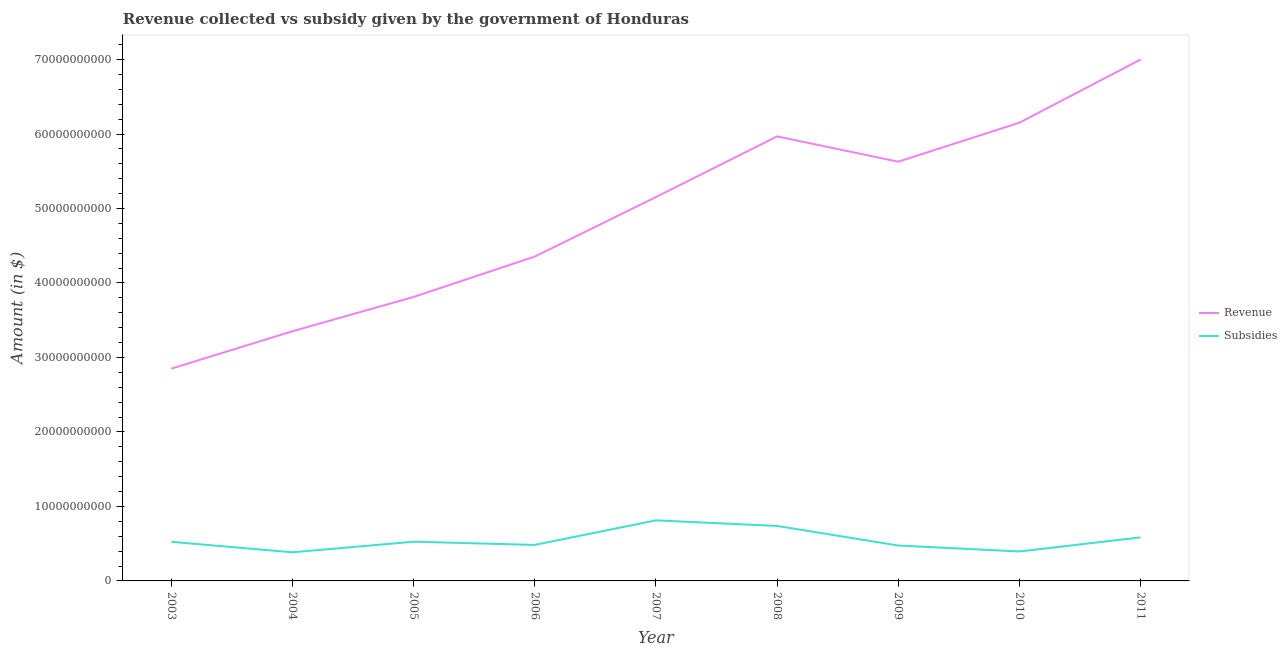How many different coloured lines are there?
Offer a terse response. 2. Does the line corresponding to amount of revenue collected intersect with the line corresponding to amount of subsidies given?
Make the answer very short. No. Is the number of lines equal to the number of legend labels?
Your response must be concise. Yes. What is the amount of revenue collected in 2011?
Make the answer very short. 7.00e+1. Across all years, what is the maximum amount of revenue collected?
Keep it short and to the point. 7.00e+1. Across all years, what is the minimum amount of revenue collected?
Offer a very short reply. 2.85e+1. In which year was the amount of subsidies given maximum?
Offer a very short reply. 2007. What is the total amount of revenue collected in the graph?
Your answer should be very brief. 4.43e+11. What is the difference between the amount of revenue collected in 2005 and that in 2006?
Offer a very short reply. -5.42e+09. What is the difference between the amount of revenue collected in 2006 and the amount of subsidies given in 2007?
Your response must be concise. 3.54e+1. What is the average amount of revenue collected per year?
Provide a short and direct response. 4.92e+1. In the year 2011, what is the difference between the amount of subsidies given and amount of revenue collected?
Give a very brief answer. -6.42e+1. In how many years, is the amount of subsidies given greater than 42000000000 $?
Offer a very short reply. 0. What is the ratio of the amount of revenue collected in 2004 to that in 2008?
Keep it short and to the point. 0.56. What is the difference between the highest and the second highest amount of subsidies given?
Give a very brief answer. 7.53e+08. What is the difference between the highest and the lowest amount of subsidies given?
Provide a short and direct response. 4.29e+09. Is the sum of the amount of subsidies given in 2003 and 2010 greater than the maximum amount of revenue collected across all years?
Ensure brevity in your answer.  No. Does the amount of revenue collected monotonically increase over the years?
Keep it short and to the point. No. Is the amount of subsidies given strictly greater than the amount of revenue collected over the years?
Your answer should be very brief. No. Is the amount of subsidies given strictly less than the amount of revenue collected over the years?
Make the answer very short. Yes. How many years are there in the graph?
Provide a succinct answer. 9. What is the difference between two consecutive major ticks on the Y-axis?
Your answer should be very brief. 1.00e+1. Does the graph contain any zero values?
Keep it short and to the point. No. Does the graph contain grids?
Your response must be concise. No. Where does the legend appear in the graph?
Keep it short and to the point. Center right. What is the title of the graph?
Your answer should be compact. Revenue collected vs subsidy given by the government of Honduras. What is the label or title of the X-axis?
Your answer should be very brief. Year. What is the label or title of the Y-axis?
Ensure brevity in your answer.  Amount (in $). What is the Amount (in $) of Revenue in 2003?
Ensure brevity in your answer.  2.85e+1. What is the Amount (in $) in Subsidies in 2003?
Keep it short and to the point. 5.25e+09. What is the Amount (in $) in Revenue in 2004?
Keep it short and to the point. 3.35e+1. What is the Amount (in $) in Subsidies in 2004?
Give a very brief answer. 3.84e+09. What is the Amount (in $) of Revenue in 2005?
Make the answer very short. 3.81e+1. What is the Amount (in $) of Subsidies in 2005?
Your response must be concise. 5.27e+09. What is the Amount (in $) in Revenue in 2006?
Your answer should be compact. 4.35e+1. What is the Amount (in $) of Subsidies in 2006?
Offer a very short reply. 4.83e+09. What is the Amount (in $) of Revenue in 2007?
Ensure brevity in your answer.  5.15e+1. What is the Amount (in $) of Subsidies in 2007?
Offer a terse response. 8.13e+09. What is the Amount (in $) of Revenue in 2008?
Your answer should be compact. 5.97e+1. What is the Amount (in $) in Subsidies in 2008?
Provide a short and direct response. 7.38e+09. What is the Amount (in $) in Revenue in 2009?
Provide a short and direct response. 5.63e+1. What is the Amount (in $) in Subsidies in 2009?
Keep it short and to the point. 4.75e+09. What is the Amount (in $) of Revenue in 2010?
Your answer should be very brief. 6.15e+1. What is the Amount (in $) of Subsidies in 2010?
Your answer should be very brief. 3.95e+09. What is the Amount (in $) in Revenue in 2011?
Your response must be concise. 7.00e+1. What is the Amount (in $) in Subsidies in 2011?
Your answer should be compact. 5.84e+09. Across all years, what is the maximum Amount (in $) in Revenue?
Your response must be concise. 7.00e+1. Across all years, what is the maximum Amount (in $) of Subsidies?
Your answer should be compact. 8.13e+09. Across all years, what is the minimum Amount (in $) in Revenue?
Offer a terse response. 2.85e+1. Across all years, what is the minimum Amount (in $) in Subsidies?
Give a very brief answer. 3.84e+09. What is the total Amount (in $) of Revenue in the graph?
Your answer should be compact. 4.43e+11. What is the total Amount (in $) in Subsidies in the graph?
Offer a very short reply. 4.93e+1. What is the difference between the Amount (in $) of Revenue in 2003 and that in 2004?
Provide a succinct answer. -5.02e+09. What is the difference between the Amount (in $) in Subsidies in 2003 and that in 2004?
Make the answer very short. 1.41e+09. What is the difference between the Amount (in $) of Revenue in 2003 and that in 2005?
Your response must be concise. -9.63e+09. What is the difference between the Amount (in $) in Subsidies in 2003 and that in 2005?
Offer a terse response. -1.57e+07. What is the difference between the Amount (in $) in Revenue in 2003 and that in 2006?
Offer a terse response. -1.50e+1. What is the difference between the Amount (in $) of Subsidies in 2003 and that in 2006?
Make the answer very short. 4.17e+08. What is the difference between the Amount (in $) in Revenue in 2003 and that in 2007?
Ensure brevity in your answer.  -2.30e+1. What is the difference between the Amount (in $) of Subsidies in 2003 and that in 2007?
Make the answer very short. -2.88e+09. What is the difference between the Amount (in $) of Revenue in 2003 and that in 2008?
Offer a very short reply. -3.12e+1. What is the difference between the Amount (in $) in Subsidies in 2003 and that in 2008?
Provide a succinct answer. -2.13e+09. What is the difference between the Amount (in $) in Revenue in 2003 and that in 2009?
Your answer should be very brief. -2.78e+1. What is the difference between the Amount (in $) in Subsidies in 2003 and that in 2009?
Provide a succinct answer. 4.99e+08. What is the difference between the Amount (in $) of Revenue in 2003 and that in 2010?
Provide a short and direct response. -3.30e+1. What is the difference between the Amount (in $) in Subsidies in 2003 and that in 2010?
Ensure brevity in your answer.  1.30e+09. What is the difference between the Amount (in $) of Revenue in 2003 and that in 2011?
Ensure brevity in your answer.  -4.15e+1. What is the difference between the Amount (in $) in Subsidies in 2003 and that in 2011?
Provide a short and direct response. -5.92e+08. What is the difference between the Amount (in $) of Revenue in 2004 and that in 2005?
Give a very brief answer. -4.61e+09. What is the difference between the Amount (in $) of Subsidies in 2004 and that in 2005?
Keep it short and to the point. -1.43e+09. What is the difference between the Amount (in $) in Revenue in 2004 and that in 2006?
Offer a terse response. -1.00e+1. What is the difference between the Amount (in $) in Subsidies in 2004 and that in 2006?
Provide a succinct answer. -9.93e+08. What is the difference between the Amount (in $) of Revenue in 2004 and that in 2007?
Offer a very short reply. -1.80e+1. What is the difference between the Amount (in $) in Subsidies in 2004 and that in 2007?
Provide a short and direct response. -4.29e+09. What is the difference between the Amount (in $) of Revenue in 2004 and that in 2008?
Keep it short and to the point. -2.62e+1. What is the difference between the Amount (in $) of Subsidies in 2004 and that in 2008?
Offer a very short reply. -3.54e+09. What is the difference between the Amount (in $) in Revenue in 2004 and that in 2009?
Make the answer very short. -2.28e+1. What is the difference between the Amount (in $) of Subsidies in 2004 and that in 2009?
Make the answer very short. -9.11e+08. What is the difference between the Amount (in $) of Revenue in 2004 and that in 2010?
Offer a terse response. -2.80e+1. What is the difference between the Amount (in $) of Subsidies in 2004 and that in 2010?
Offer a very short reply. -1.11e+08. What is the difference between the Amount (in $) in Revenue in 2004 and that in 2011?
Make the answer very short. -3.65e+1. What is the difference between the Amount (in $) of Subsidies in 2004 and that in 2011?
Make the answer very short. -2.00e+09. What is the difference between the Amount (in $) of Revenue in 2005 and that in 2006?
Provide a succinct answer. -5.42e+09. What is the difference between the Amount (in $) in Subsidies in 2005 and that in 2006?
Offer a terse response. 4.33e+08. What is the difference between the Amount (in $) in Revenue in 2005 and that in 2007?
Your answer should be very brief. -1.34e+1. What is the difference between the Amount (in $) in Subsidies in 2005 and that in 2007?
Your answer should be very brief. -2.87e+09. What is the difference between the Amount (in $) in Revenue in 2005 and that in 2008?
Give a very brief answer. -2.16e+1. What is the difference between the Amount (in $) in Subsidies in 2005 and that in 2008?
Keep it short and to the point. -2.11e+09. What is the difference between the Amount (in $) of Revenue in 2005 and that in 2009?
Your answer should be compact. -1.82e+1. What is the difference between the Amount (in $) of Subsidies in 2005 and that in 2009?
Your answer should be very brief. 5.14e+08. What is the difference between the Amount (in $) of Revenue in 2005 and that in 2010?
Keep it short and to the point. -2.34e+1. What is the difference between the Amount (in $) in Subsidies in 2005 and that in 2010?
Your response must be concise. 1.31e+09. What is the difference between the Amount (in $) in Revenue in 2005 and that in 2011?
Your answer should be compact. -3.19e+1. What is the difference between the Amount (in $) of Subsidies in 2005 and that in 2011?
Ensure brevity in your answer.  -5.76e+08. What is the difference between the Amount (in $) in Revenue in 2006 and that in 2007?
Make the answer very short. -7.99e+09. What is the difference between the Amount (in $) in Subsidies in 2006 and that in 2007?
Give a very brief answer. -3.30e+09. What is the difference between the Amount (in $) in Revenue in 2006 and that in 2008?
Give a very brief answer. -1.61e+1. What is the difference between the Amount (in $) of Subsidies in 2006 and that in 2008?
Offer a terse response. -2.55e+09. What is the difference between the Amount (in $) of Revenue in 2006 and that in 2009?
Keep it short and to the point. -1.27e+1. What is the difference between the Amount (in $) in Subsidies in 2006 and that in 2009?
Provide a short and direct response. 8.13e+07. What is the difference between the Amount (in $) of Revenue in 2006 and that in 2010?
Provide a succinct answer. -1.80e+1. What is the difference between the Amount (in $) in Subsidies in 2006 and that in 2010?
Make the answer very short. 8.81e+08. What is the difference between the Amount (in $) of Revenue in 2006 and that in 2011?
Keep it short and to the point. -2.65e+1. What is the difference between the Amount (in $) of Subsidies in 2006 and that in 2011?
Your answer should be compact. -1.01e+09. What is the difference between the Amount (in $) of Revenue in 2007 and that in 2008?
Keep it short and to the point. -8.15e+09. What is the difference between the Amount (in $) of Subsidies in 2007 and that in 2008?
Your response must be concise. 7.53e+08. What is the difference between the Amount (in $) of Revenue in 2007 and that in 2009?
Provide a short and direct response. -4.75e+09. What is the difference between the Amount (in $) in Subsidies in 2007 and that in 2009?
Make the answer very short. 3.38e+09. What is the difference between the Amount (in $) in Revenue in 2007 and that in 2010?
Provide a short and direct response. -9.98e+09. What is the difference between the Amount (in $) in Subsidies in 2007 and that in 2010?
Make the answer very short. 4.18e+09. What is the difference between the Amount (in $) in Revenue in 2007 and that in 2011?
Your response must be concise. -1.85e+1. What is the difference between the Amount (in $) of Subsidies in 2007 and that in 2011?
Your answer should be compact. 2.29e+09. What is the difference between the Amount (in $) in Revenue in 2008 and that in 2009?
Your response must be concise. 3.40e+09. What is the difference between the Amount (in $) in Subsidies in 2008 and that in 2009?
Give a very brief answer. 2.63e+09. What is the difference between the Amount (in $) of Revenue in 2008 and that in 2010?
Make the answer very short. -1.84e+09. What is the difference between the Amount (in $) of Subsidies in 2008 and that in 2010?
Your response must be concise. 3.43e+09. What is the difference between the Amount (in $) of Revenue in 2008 and that in 2011?
Make the answer very short. -1.03e+1. What is the difference between the Amount (in $) of Subsidies in 2008 and that in 2011?
Provide a succinct answer. 1.54e+09. What is the difference between the Amount (in $) of Revenue in 2009 and that in 2010?
Offer a terse response. -5.23e+09. What is the difference between the Amount (in $) of Subsidies in 2009 and that in 2010?
Provide a succinct answer. 8.00e+08. What is the difference between the Amount (in $) of Revenue in 2009 and that in 2011?
Provide a succinct answer. -1.37e+1. What is the difference between the Amount (in $) in Subsidies in 2009 and that in 2011?
Ensure brevity in your answer.  -1.09e+09. What is the difference between the Amount (in $) in Revenue in 2010 and that in 2011?
Your answer should be very brief. -8.49e+09. What is the difference between the Amount (in $) in Subsidies in 2010 and that in 2011?
Give a very brief answer. -1.89e+09. What is the difference between the Amount (in $) of Revenue in 2003 and the Amount (in $) of Subsidies in 2004?
Give a very brief answer. 2.47e+1. What is the difference between the Amount (in $) in Revenue in 2003 and the Amount (in $) in Subsidies in 2005?
Your response must be concise. 2.32e+1. What is the difference between the Amount (in $) of Revenue in 2003 and the Amount (in $) of Subsidies in 2006?
Ensure brevity in your answer.  2.37e+1. What is the difference between the Amount (in $) in Revenue in 2003 and the Amount (in $) in Subsidies in 2007?
Ensure brevity in your answer.  2.04e+1. What is the difference between the Amount (in $) of Revenue in 2003 and the Amount (in $) of Subsidies in 2008?
Your answer should be very brief. 2.11e+1. What is the difference between the Amount (in $) in Revenue in 2003 and the Amount (in $) in Subsidies in 2009?
Give a very brief answer. 2.37e+1. What is the difference between the Amount (in $) of Revenue in 2003 and the Amount (in $) of Subsidies in 2010?
Your response must be concise. 2.45e+1. What is the difference between the Amount (in $) in Revenue in 2003 and the Amount (in $) in Subsidies in 2011?
Your answer should be very brief. 2.27e+1. What is the difference between the Amount (in $) in Revenue in 2004 and the Amount (in $) in Subsidies in 2005?
Give a very brief answer. 2.83e+1. What is the difference between the Amount (in $) in Revenue in 2004 and the Amount (in $) in Subsidies in 2006?
Ensure brevity in your answer.  2.87e+1. What is the difference between the Amount (in $) in Revenue in 2004 and the Amount (in $) in Subsidies in 2007?
Provide a succinct answer. 2.54e+1. What is the difference between the Amount (in $) of Revenue in 2004 and the Amount (in $) of Subsidies in 2008?
Provide a succinct answer. 2.61e+1. What is the difference between the Amount (in $) in Revenue in 2004 and the Amount (in $) in Subsidies in 2009?
Offer a terse response. 2.88e+1. What is the difference between the Amount (in $) of Revenue in 2004 and the Amount (in $) of Subsidies in 2010?
Provide a short and direct response. 2.96e+1. What is the difference between the Amount (in $) of Revenue in 2004 and the Amount (in $) of Subsidies in 2011?
Give a very brief answer. 2.77e+1. What is the difference between the Amount (in $) of Revenue in 2005 and the Amount (in $) of Subsidies in 2006?
Ensure brevity in your answer.  3.33e+1. What is the difference between the Amount (in $) of Revenue in 2005 and the Amount (in $) of Subsidies in 2007?
Your answer should be compact. 3.00e+1. What is the difference between the Amount (in $) of Revenue in 2005 and the Amount (in $) of Subsidies in 2008?
Provide a succinct answer. 3.07e+1. What is the difference between the Amount (in $) in Revenue in 2005 and the Amount (in $) in Subsidies in 2009?
Provide a succinct answer. 3.34e+1. What is the difference between the Amount (in $) of Revenue in 2005 and the Amount (in $) of Subsidies in 2010?
Your response must be concise. 3.42e+1. What is the difference between the Amount (in $) of Revenue in 2005 and the Amount (in $) of Subsidies in 2011?
Provide a succinct answer. 3.23e+1. What is the difference between the Amount (in $) in Revenue in 2006 and the Amount (in $) in Subsidies in 2007?
Provide a succinct answer. 3.54e+1. What is the difference between the Amount (in $) in Revenue in 2006 and the Amount (in $) in Subsidies in 2008?
Your answer should be compact. 3.62e+1. What is the difference between the Amount (in $) in Revenue in 2006 and the Amount (in $) in Subsidies in 2009?
Give a very brief answer. 3.88e+1. What is the difference between the Amount (in $) in Revenue in 2006 and the Amount (in $) in Subsidies in 2010?
Your response must be concise. 3.96e+1. What is the difference between the Amount (in $) in Revenue in 2006 and the Amount (in $) in Subsidies in 2011?
Keep it short and to the point. 3.77e+1. What is the difference between the Amount (in $) of Revenue in 2007 and the Amount (in $) of Subsidies in 2008?
Provide a short and direct response. 4.42e+1. What is the difference between the Amount (in $) of Revenue in 2007 and the Amount (in $) of Subsidies in 2009?
Provide a short and direct response. 4.68e+1. What is the difference between the Amount (in $) of Revenue in 2007 and the Amount (in $) of Subsidies in 2010?
Offer a terse response. 4.76e+1. What is the difference between the Amount (in $) of Revenue in 2007 and the Amount (in $) of Subsidies in 2011?
Make the answer very short. 4.57e+1. What is the difference between the Amount (in $) of Revenue in 2008 and the Amount (in $) of Subsidies in 2009?
Your response must be concise. 5.49e+1. What is the difference between the Amount (in $) in Revenue in 2008 and the Amount (in $) in Subsidies in 2010?
Give a very brief answer. 5.57e+1. What is the difference between the Amount (in $) of Revenue in 2008 and the Amount (in $) of Subsidies in 2011?
Your response must be concise. 5.38e+1. What is the difference between the Amount (in $) of Revenue in 2009 and the Amount (in $) of Subsidies in 2010?
Give a very brief answer. 5.23e+1. What is the difference between the Amount (in $) of Revenue in 2009 and the Amount (in $) of Subsidies in 2011?
Provide a succinct answer. 5.04e+1. What is the difference between the Amount (in $) of Revenue in 2010 and the Amount (in $) of Subsidies in 2011?
Give a very brief answer. 5.57e+1. What is the average Amount (in $) in Revenue per year?
Ensure brevity in your answer.  4.92e+1. What is the average Amount (in $) of Subsidies per year?
Offer a very short reply. 5.47e+09. In the year 2003, what is the difference between the Amount (in $) in Revenue and Amount (in $) in Subsidies?
Keep it short and to the point. 2.32e+1. In the year 2004, what is the difference between the Amount (in $) in Revenue and Amount (in $) in Subsidies?
Make the answer very short. 2.97e+1. In the year 2005, what is the difference between the Amount (in $) of Revenue and Amount (in $) of Subsidies?
Offer a terse response. 3.29e+1. In the year 2006, what is the difference between the Amount (in $) in Revenue and Amount (in $) in Subsidies?
Ensure brevity in your answer.  3.87e+1. In the year 2007, what is the difference between the Amount (in $) in Revenue and Amount (in $) in Subsidies?
Offer a terse response. 4.34e+1. In the year 2008, what is the difference between the Amount (in $) in Revenue and Amount (in $) in Subsidies?
Your answer should be very brief. 5.23e+1. In the year 2009, what is the difference between the Amount (in $) in Revenue and Amount (in $) in Subsidies?
Ensure brevity in your answer.  5.15e+1. In the year 2010, what is the difference between the Amount (in $) in Revenue and Amount (in $) in Subsidies?
Ensure brevity in your answer.  5.76e+1. In the year 2011, what is the difference between the Amount (in $) of Revenue and Amount (in $) of Subsidies?
Provide a succinct answer. 6.42e+1. What is the ratio of the Amount (in $) of Revenue in 2003 to that in 2004?
Provide a short and direct response. 0.85. What is the ratio of the Amount (in $) in Subsidies in 2003 to that in 2004?
Keep it short and to the point. 1.37. What is the ratio of the Amount (in $) of Revenue in 2003 to that in 2005?
Your answer should be compact. 0.75. What is the ratio of the Amount (in $) of Revenue in 2003 to that in 2006?
Offer a terse response. 0.65. What is the ratio of the Amount (in $) of Subsidies in 2003 to that in 2006?
Offer a very short reply. 1.09. What is the ratio of the Amount (in $) of Revenue in 2003 to that in 2007?
Ensure brevity in your answer.  0.55. What is the ratio of the Amount (in $) in Subsidies in 2003 to that in 2007?
Ensure brevity in your answer.  0.65. What is the ratio of the Amount (in $) of Revenue in 2003 to that in 2008?
Offer a very short reply. 0.48. What is the ratio of the Amount (in $) in Subsidies in 2003 to that in 2008?
Ensure brevity in your answer.  0.71. What is the ratio of the Amount (in $) in Revenue in 2003 to that in 2009?
Your answer should be very brief. 0.51. What is the ratio of the Amount (in $) of Subsidies in 2003 to that in 2009?
Your answer should be very brief. 1.1. What is the ratio of the Amount (in $) of Revenue in 2003 to that in 2010?
Your response must be concise. 0.46. What is the ratio of the Amount (in $) in Subsidies in 2003 to that in 2010?
Ensure brevity in your answer.  1.33. What is the ratio of the Amount (in $) of Revenue in 2003 to that in 2011?
Your answer should be very brief. 0.41. What is the ratio of the Amount (in $) in Subsidies in 2003 to that in 2011?
Keep it short and to the point. 0.9. What is the ratio of the Amount (in $) of Revenue in 2004 to that in 2005?
Offer a very short reply. 0.88. What is the ratio of the Amount (in $) of Subsidies in 2004 to that in 2005?
Keep it short and to the point. 0.73. What is the ratio of the Amount (in $) of Revenue in 2004 to that in 2006?
Keep it short and to the point. 0.77. What is the ratio of the Amount (in $) in Subsidies in 2004 to that in 2006?
Ensure brevity in your answer.  0.79. What is the ratio of the Amount (in $) of Revenue in 2004 to that in 2007?
Your answer should be very brief. 0.65. What is the ratio of the Amount (in $) of Subsidies in 2004 to that in 2007?
Make the answer very short. 0.47. What is the ratio of the Amount (in $) of Revenue in 2004 to that in 2008?
Offer a terse response. 0.56. What is the ratio of the Amount (in $) in Subsidies in 2004 to that in 2008?
Your answer should be compact. 0.52. What is the ratio of the Amount (in $) in Revenue in 2004 to that in 2009?
Give a very brief answer. 0.6. What is the ratio of the Amount (in $) of Subsidies in 2004 to that in 2009?
Keep it short and to the point. 0.81. What is the ratio of the Amount (in $) in Revenue in 2004 to that in 2010?
Offer a very short reply. 0.54. What is the ratio of the Amount (in $) in Subsidies in 2004 to that in 2010?
Provide a succinct answer. 0.97. What is the ratio of the Amount (in $) in Revenue in 2004 to that in 2011?
Ensure brevity in your answer.  0.48. What is the ratio of the Amount (in $) of Subsidies in 2004 to that in 2011?
Offer a terse response. 0.66. What is the ratio of the Amount (in $) in Revenue in 2005 to that in 2006?
Provide a short and direct response. 0.88. What is the ratio of the Amount (in $) of Subsidies in 2005 to that in 2006?
Give a very brief answer. 1.09. What is the ratio of the Amount (in $) in Revenue in 2005 to that in 2007?
Offer a terse response. 0.74. What is the ratio of the Amount (in $) in Subsidies in 2005 to that in 2007?
Keep it short and to the point. 0.65. What is the ratio of the Amount (in $) in Revenue in 2005 to that in 2008?
Your answer should be very brief. 0.64. What is the ratio of the Amount (in $) in Subsidies in 2005 to that in 2008?
Your answer should be very brief. 0.71. What is the ratio of the Amount (in $) of Revenue in 2005 to that in 2009?
Make the answer very short. 0.68. What is the ratio of the Amount (in $) in Subsidies in 2005 to that in 2009?
Ensure brevity in your answer.  1.11. What is the ratio of the Amount (in $) in Revenue in 2005 to that in 2010?
Offer a very short reply. 0.62. What is the ratio of the Amount (in $) of Subsidies in 2005 to that in 2010?
Your answer should be very brief. 1.33. What is the ratio of the Amount (in $) in Revenue in 2005 to that in 2011?
Provide a succinct answer. 0.54. What is the ratio of the Amount (in $) of Subsidies in 2005 to that in 2011?
Your answer should be compact. 0.9. What is the ratio of the Amount (in $) of Revenue in 2006 to that in 2007?
Your answer should be compact. 0.84. What is the ratio of the Amount (in $) of Subsidies in 2006 to that in 2007?
Make the answer very short. 0.59. What is the ratio of the Amount (in $) of Revenue in 2006 to that in 2008?
Make the answer very short. 0.73. What is the ratio of the Amount (in $) of Subsidies in 2006 to that in 2008?
Your response must be concise. 0.66. What is the ratio of the Amount (in $) in Revenue in 2006 to that in 2009?
Ensure brevity in your answer.  0.77. What is the ratio of the Amount (in $) of Subsidies in 2006 to that in 2009?
Your answer should be compact. 1.02. What is the ratio of the Amount (in $) of Revenue in 2006 to that in 2010?
Your answer should be very brief. 0.71. What is the ratio of the Amount (in $) of Subsidies in 2006 to that in 2010?
Your answer should be very brief. 1.22. What is the ratio of the Amount (in $) in Revenue in 2006 to that in 2011?
Your answer should be very brief. 0.62. What is the ratio of the Amount (in $) in Subsidies in 2006 to that in 2011?
Make the answer very short. 0.83. What is the ratio of the Amount (in $) in Revenue in 2007 to that in 2008?
Give a very brief answer. 0.86. What is the ratio of the Amount (in $) of Subsidies in 2007 to that in 2008?
Your answer should be very brief. 1.1. What is the ratio of the Amount (in $) in Revenue in 2007 to that in 2009?
Your response must be concise. 0.92. What is the ratio of the Amount (in $) of Subsidies in 2007 to that in 2009?
Keep it short and to the point. 1.71. What is the ratio of the Amount (in $) of Revenue in 2007 to that in 2010?
Offer a very short reply. 0.84. What is the ratio of the Amount (in $) in Subsidies in 2007 to that in 2010?
Give a very brief answer. 2.06. What is the ratio of the Amount (in $) of Revenue in 2007 to that in 2011?
Provide a short and direct response. 0.74. What is the ratio of the Amount (in $) of Subsidies in 2007 to that in 2011?
Provide a succinct answer. 1.39. What is the ratio of the Amount (in $) of Revenue in 2008 to that in 2009?
Provide a succinct answer. 1.06. What is the ratio of the Amount (in $) of Subsidies in 2008 to that in 2009?
Give a very brief answer. 1.55. What is the ratio of the Amount (in $) of Revenue in 2008 to that in 2010?
Offer a very short reply. 0.97. What is the ratio of the Amount (in $) of Subsidies in 2008 to that in 2010?
Make the answer very short. 1.87. What is the ratio of the Amount (in $) in Revenue in 2008 to that in 2011?
Your answer should be compact. 0.85. What is the ratio of the Amount (in $) in Subsidies in 2008 to that in 2011?
Your answer should be very brief. 1.26. What is the ratio of the Amount (in $) of Revenue in 2009 to that in 2010?
Make the answer very short. 0.91. What is the ratio of the Amount (in $) in Subsidies in 2009 to that in 2010?
Your answer should be very brief. 1.2. What is the ratio of the Amount (in $) of Revenue in 2009 to that in 2011?
Offer a terse response. 0.8. What is the ratio of the Amount (in $) in Subsidies in 2009 to that in 2011?
Make the answer very short. 0.81. What is the ratio of the Amount (in $) of Revenue in 2010 to that in 2011?
Your answer should be compact. 0.88. What is the ratio of the Amount (in $) of Subsidies in 2010 to that in 2011?
Give a very brief answer. 0.68. What is the difference between the highest and the second highest Amount (in $) in Revenue?
Your response must be concise. 8.49e+09. What is the difference between the highest and the second highest Amount (in $) of Subsidies?
Offer a very short reply. 7.53e+08. What is the difference between the highest and the lowest Amount (in $) in Revenue?
Your answer should be very brief. 4.15e+1. What is the difference between the highest and the lowest Amount (in $) in Subsidies?
Your answer should be very brief. 4.29e+09. 